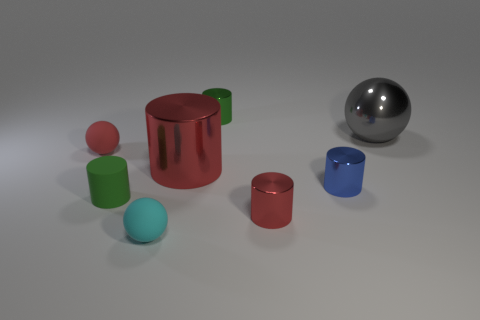Subtract 2 cylinders. How many cylinders are left? 3 Subtract all blue cylinders. How many cylinders are left? 4 Subtract all blue cylinders. How many cylinders are left? 4 Subtract all yellow cylinders. Subtract all cyan cubes. How many cylinders are left? 5 Add 2 gray shiny cubes. How many objects exist? 10 Subtract all cylinders. How many objects are left? 3 Add 7 small red shiny cylinders. How many small red shiny cylinders are left? 8 Add 3 small metallic things. How many small metallic things exist? 6 Subtract 0 cyan cubes. How many objects are left? 8 Subtract all cyan balls. Subtract all gray things. How many objects are left? 6 